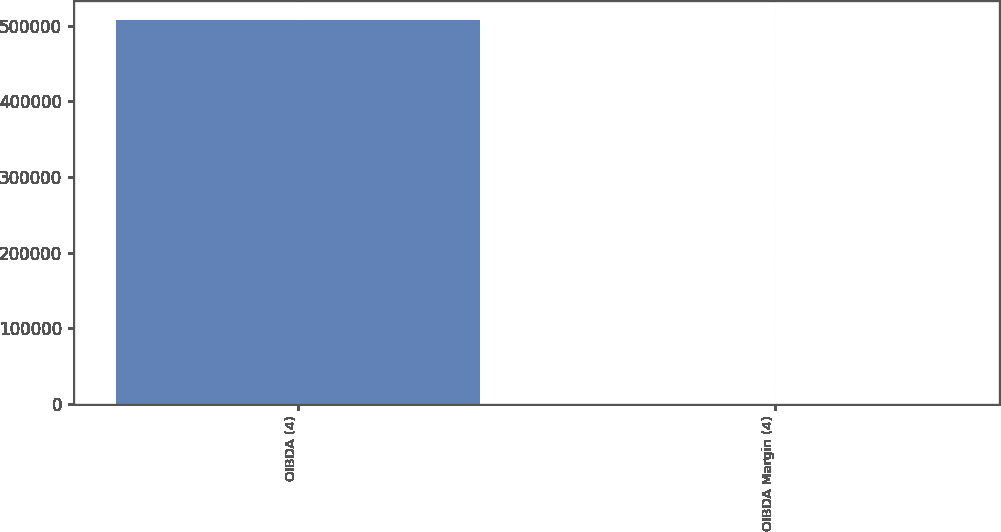<chart> <loc_0><loc_0><loc_500><loc_500><bar_chart><fcel>OIBDA (4)<fcel>OIBDA Margin (4)<nl><fcel>508125<fcel>28<nl></chart> 